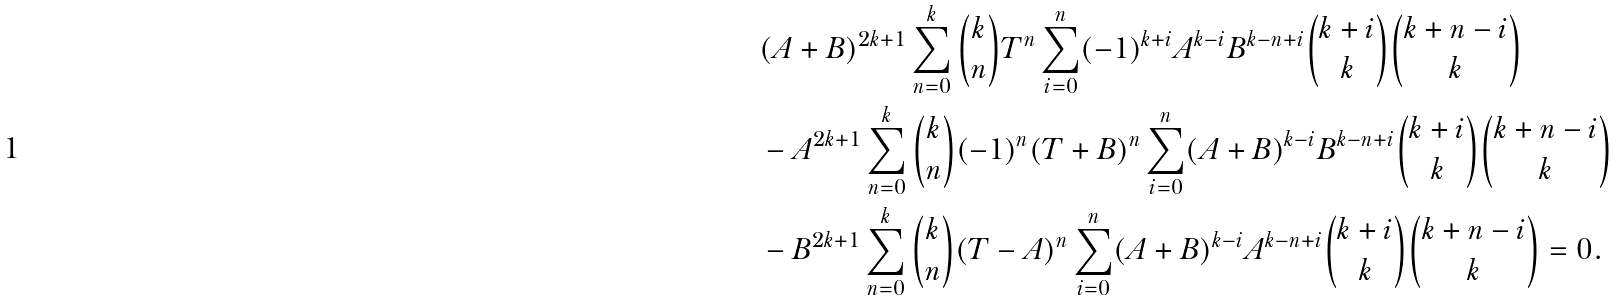Convert formula to latex. <formula><loc_0><loc_0><loc_500><loc_500>& ( A + B ) ^ { 2 k + 1 } \sum _ { n = 0 } ^ { k } \binom { k } { n } T ^ { n } \sum _ { i = 0 } ^ { n } ( - 1 ) ^ { k + i } A ^ { k - i } B ^ { k - n + i } \binom { k + i } { k } \binom { k + n - i } { k } \\ & - A ^ { 2 k + 1 } \sum _ { n = 0 } ^ { k } \binom { k } { n } ( - 1 ) ^ { n } ( T + B ) ^ { n } \sum _ { i = 0 } ^ { n } ( A + B ) ^ { k - i } B ^ { k - n + i } \binom { k + i } { k } \binom { k + n - i } { k } \\ & - B ^ { 2 k + 1 } \sum _ { n = 0 } ^ { k } \binom { k } { n } ( T - A ) ^ { n } \sum _ { i = 0 } ^ { n } ( A + B ) ^ { k - i } A ^ { k - n + i } \binom { k + i } { k } \binom { k + n - i } { k } = 0 .</formula> 